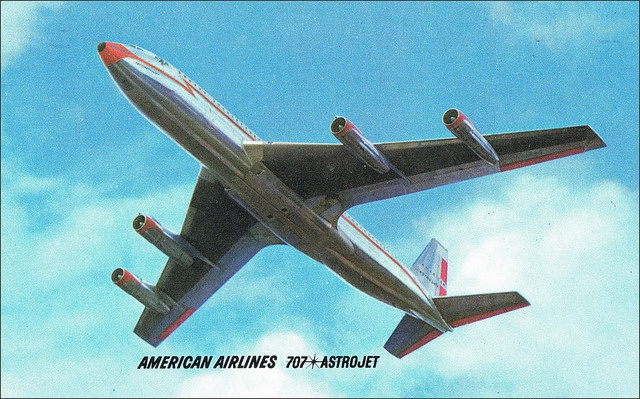Describe the objects in this image and their specific colors. I can see a airplane in black, gray, darkgreen, and lightblue tones in this image. 